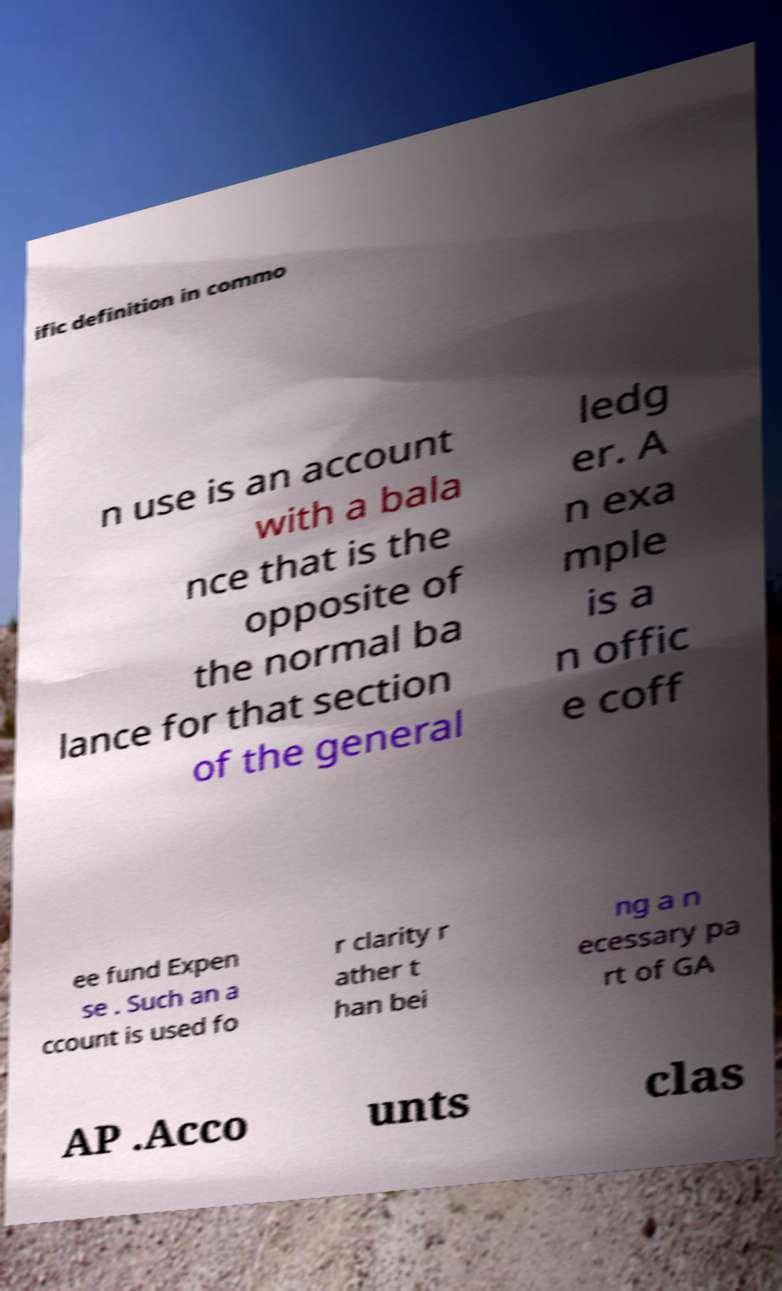Can you read and provide the text displayed in the image?This photo seems to have some interesting text. Can you extract and type it out for me? ific definition in commo n use is an account with a bala nce that is the opposite of the normal ba lance for that section of the general ledg er. A n exa mple is a n offic e coff ee fund Expen se . Such an a ccount is used fo r clarity r ather t han bei ng a n ecessary pa rt of GA AP .Acco unts clas 